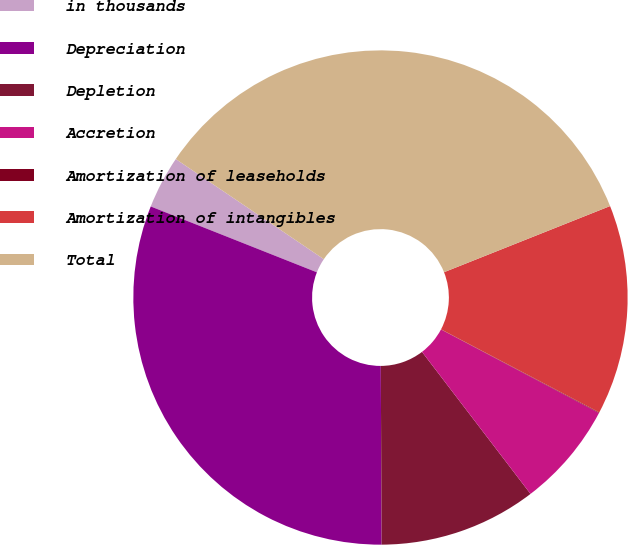Convert chart. <chart><loc_0><loc_0><loc_500><loc_500><pie_chart><fcel>in thousands<fcel>Depreciation<fcel>Depletion<fcel>Accretion<fcel>Amortization of leaseholds<fcel>Amortization of intangibles<fcel>Total<nl><fcel>3.46%<fcel>31.08%<fcel>10.31%<fcel>6.88%<fcel>0.04%<fcel>13.73%<fcel>34.5%<nl></chart> 